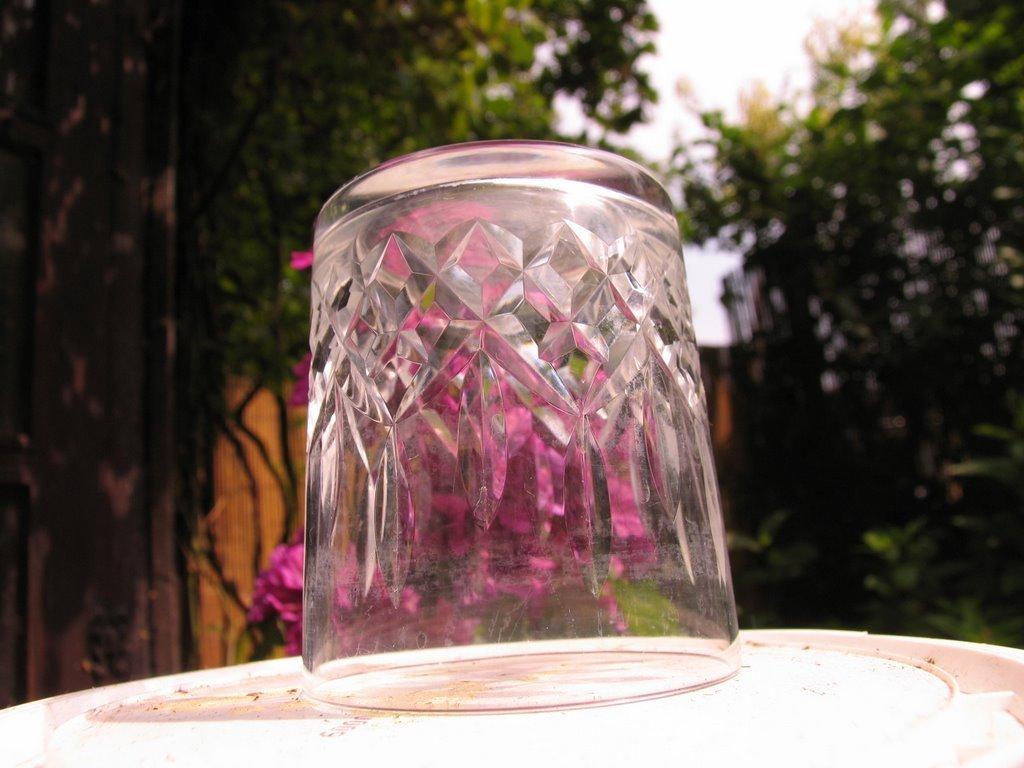Describe this image in one or two sentences. There is reverse glass on a white surface. Behind that there are pink flowers and trees. 